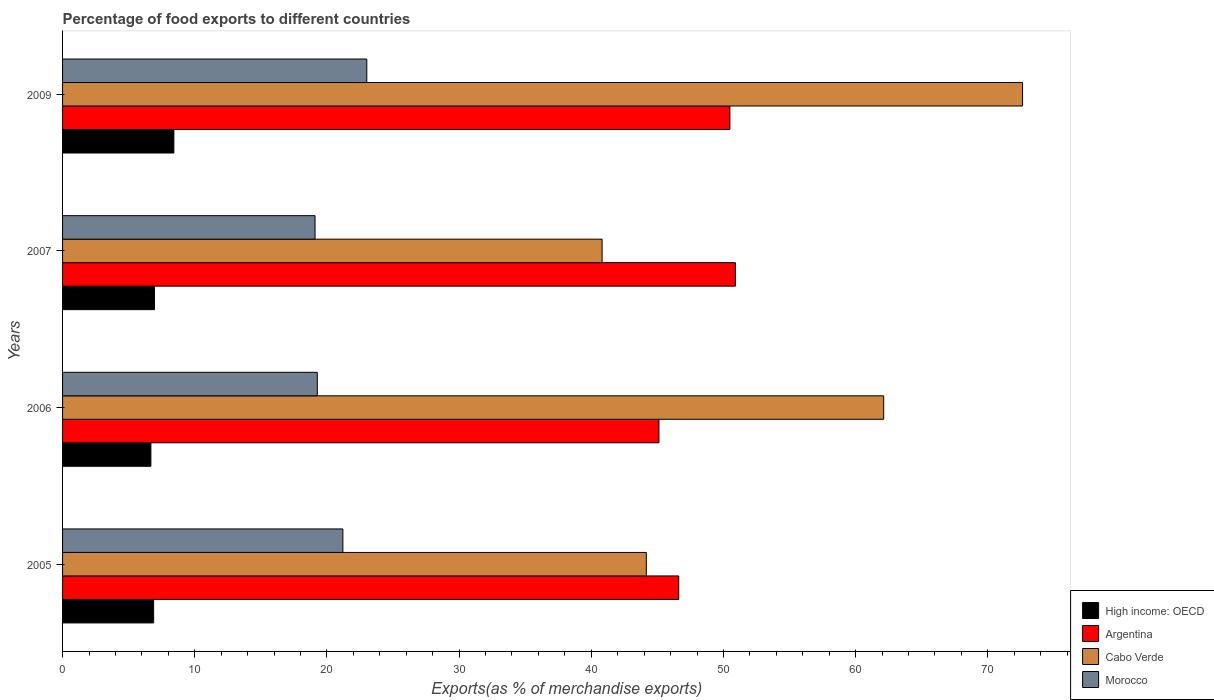Are the number of bars per tick equal to the number of legend labels?
Offer a terse response. Yes. How many bars are there on the 1st tick from the top?
Offer a very short reply. 4. How many bars are there on the 1st tick from the bottom?
Ensure brevity in your answer.  4. What is the percentage of exports to different countries in Morocco in 2006?
Ensure brevity in your answer.  19.27. Across all years, what is the maximum percentage of exports to different countries in High income: OECD?
Offer a terse response. 8.42. Across all years, what is the minimum percentage of exports to different countries in Cabo Verde?
Provide a succinct answer. 40.82. In which year was the percentage of exports to different countries in Argentina maximum?
Give a very brief answer. 2007. In which year was the percentage of exports to different countries in Cabo Verde minimum?
Keep it short and to the point. 2007. What is the total percentage of exports to different countries in Cabo Verde in the graph?
Your response must be concise. 219.74. What is the difference between the percentage of exports to different countries in Cabo Verde in 2006 and that in 2009?
Offer a terse response. -10.51. What is the difference between the percentage of exports to different countries in High income: OECD in 2005 and the percentage of exports to different countries in Cabo Verde in 2009?
Provide a succinct answer. -65.74. What is the average percentage of exports to different countries in Cabo Verde per year?
Make the answer very short. 54.94. In the year 2006, what is the difference between the percentage of exports to different countries in Cabo Verde and percentage of exports to different countries in Morocco?
Ensure brevity in your answer.  42.85. In how many years, is the percentage of exports to different countries in Cabo Verde greater than 36 %?
Give a very brief answer. 4. What is the ratio of the percentage of exports to different countries in Cabo Verde in 2006 to that in 2007?
Provide a succinct answer. 1.52. What is the difference between the highest and the second highest percentage of exports to different countries in Cabo Verde?
Your answer should be compact. 10.51. What is the difference between the highest and the lowest percentage of exports to different countries in Morocco?
Ensure brevity in your answer.  3.91. In how many years, is the percentage of exports to different countries in High income: OECD greater than the average percentage of exports to different countries in High income: OECD taken over all years?
Make the answer very short. 1. Is it the case that in every year, the sum of the percentage of exports to different countries in Morocco and percentage of exports to different countries in Cabo Verde is greater than the sum of percentage of exports to different countries in Argentina and percentage of exports to different countries in High income: OECD?
Offer a terse response. Yes. What does the 4th bar from the top in 2009 represents?
Make the answer very short. High income: OECD. How many bars are there?
Your answer should be very brief. 16. What is the difference between two consecutive major ticks on the X-axis?
Make the answer very short. 10. Are the values on the major ticks of X-axis written in scientific E-notation?
Keep it short and to the point. No. What is the title of the graph?
Give a very brief answer. Percentage of food exports to different countries. Does "Arab World" appear as one of the legend labels in the graph?
Ensure brevity in your answer.  No. What is the label or title of the X-axis?
Provide a succinct answer. Exports(as % of merchandise exports). What is the Exports(as % of merchandise exports) of High income: OECD in 2005?
Your answer should be very brief. 6.89. What is the Exports(as % of merchandise exports) in Argentina in 2005?
Offer a very short reply. 46.62. What is the Exports(as % of merchandise exports) of Cabo Verde in 2005?
Make the answer very short. 44.17. What is the Exports(as % of merchandise exports) of Morocco in 2005?
Provide a succinct answer. 21.21. What is the Exports(as % of merchandise exports) of High income: OECD in 2006?
Provide a succinct answer. 6.68. What is the Exports(as % of merchandise exports) of Argentina in 2006?
Make the answer very short. 45.12. What is the Exports(as % of merchandise exports) of Cabo Verde in 2006?
Ensure brevity in your answer.  62.12. What is the Exports(as % of merchandise exports) in Morocco in 2006?
Your answer should be compact. 19.27. What is the Exports(as % of merchandise exports) in High income: OECD in 2007?
Offer a very short reply. 6.95. What is the Exports(as % of merchandise exports) in Argentina in 2007?
Your answer should be compact. 50.91. What is the Exports(as % of merchandise exports) in Cabo Verde in 2007?
Offer a very short reply. 40.82. What is the Exports(as % of merchandise exports) in Morocco in 2007?
Keep it short and to the point. 19.1. What is the Exports(as % of merchandise exports) in High income: OECD in 2009?
Make the answer very short. 8.42. What is the Exports(as % of merchandise exports) in Argentina in 2009?
Your answer should be very brief. 50.49. What is the Exports(as % of merchandise exports) of Cabo Verde in 2009?
Your answer should be compact. 72.63. What is the Exports(as % of merchandise exports) of Morocco in 2009?
Your answer should be compact. 23.02. Across all years, what is the maximum Exports(as % of merchandise exports) of High income: OECD?
Give a very brief answer. 8.42. Across all years, what is the maximum Exports(as % of merchandise exports) in Argentina?
Keep it short and to the point. 50.91. Across all years, what is the maximum Exports(as % of merchandise exports) in Cabo Verde?
Keep it short and to the point. 72.63. Across all years, what is the maximum Exports(as % of merchandise exports) of Morocco?
Your response must be concise. 23.02. Across all years, what is the minimum Exports(as % of merchandise exports) in High income: OECD?
Keep it short and to the point. 6.68. Across all years, what is the minimum Exports(as % of merchandise exports) in Argentina?
Offer a terse response. 45.12. Across all years, what is the minimum Exports(as % of merchandise exports) of Cabo Verde?
Provide a succinct answer. 40.82. Across all years, what is the minimum Exports(as % of merchandise exports) in Morocco?
Your answer should be compact. 19.1. What is the total Exports(as % of merchandise exports) in High income: OECD in the graph?
Offer a very short reply. 28.95. What is the total Exports(as % of merchandise exports) in Argentina in the graph?
Provide a succinct answer. 193.13. What is the total Exports(as % of merchandise exports) of Cabo Verde in the graph?
Offer a terse response. 219.74. What is the total Exports(as % of merchandise exports) of Morocco in the graph?
Offer a very short reply. 82.6. What is the difference between the Exports(as % of merchandise exports) of High income: OECD in 2005 and that in 2006?
Your answer should be compact. 0.21. What is the difference between the Exports(as % of merchandise exports) in Argentina in 2005 and that in 2006?
Provide a short and direct response. 1.5. What is the difference between the Exports(as % of merchandise exports) of Cabo Verde in 2005 and that in 2006?
Ensure brevity in your answer.  -17.96. What is the difference between the Exports(as % of merchandise exports) of Morocco in 2005 and that in 2006?
Offer a very short reply. 1.93. What is the difference between the Exports(as % of merchandise exports) in High income: OECD in 2005 and that in 2007?
Offer a terse response. -0.06. What is the difference between the Exports(as % of merchandise exports) in Argentina in 2005 and that in 2007?
Provide a short and direct response. -4.29. What is the difference between the Exports(as % of merchandise exports) of Cabo Verde in 2005 and that in 2007?
Give a very brief answer. 3.35. What is the difference between the Exports(as % of merchandise exports) of Morocco in 2005 and that in 2007?
Give a very brief answer. 2.1. What is the difference between the Exports(as % of merchandise exports) in High income: OECD in 2005 and that in 2009?
Your answer should be very brief. -1.53. What is the difference between the Exports(as % of merchandise exports) in Argentina in 2005 and that in 2009?
Make the answer very short. -3.87. What is the difference between the Exports(as % of merchandise exports) of Cabo Verde in 2005 and that in 2009?
Offer a very short reply. -28.47. What is the difference between the Exports(as % of merchandise exports) in Morocco in 2005 and that in 2009?
Offer a very short reply. -1.81. What is the difference between the Exports(as % of merchandise exports) of High income: OECD in 2006 and that in 2007?
Provide a succinct answer. -0.27. What is the difference between the Exports(as % of merchandise exports) in Argentina in 2006 and that in 2007?
Provide a short and direct response. -5.79. What is the difference between the Exports(as % of merchandise exports) in Cabo Verde in 2006 and that in 2007?
Provide a short and direct response. 21.31. What is the difference between the Exports(as % of merchandise exports) of Morocco in 2006 and that in 2007?
Provide a short and direct response. 0.17. What is the difference between the Exports(as % of merchandise exports) of High income: OECD in 2006 and that in 2009?
Your response must be concise. -1.74. What is the difference between the Exports(as % of merchandise exports) in Argentina in 2006 and that in 2009?
Your answer should be very brief. -5.37. What is the difference between the Exports(as % of merchandise exports) in Cabo Verde in 2006 and that in 2009?
Your response must be concise. -10.51. What is the difference between the Exports(as % of merchandise exports) in Morocco in 2006 and that in 2009?
Your answer should be very brief. -3.74. What is the difference between the Exports(as % of merchandise exports) of High income: OECD in 2007 and that in 2009?
Your answer should be compact. -1.47. What is the difference between the Exports(as % of merchandise exports) in Argentina in 2007 and that in 2009?
Offer a terse response. 0.42. What is the difference between the Exports(as % of merchandise exports) in Cabo Verde in 2007 and that in 2009?
Your response must be concise. -31.81. What is the difference between the Exports(as % of merchandise exports) in Morocco in 2007 and that in 2009?
Your answer should be compact. -3.91. What is the difference between the Exports(as % of merchandise exports) in High income: OECD in 2005 and the Exports(as % of merchandise exports) in Argentina in 2006?
Provide a succinct answer. -38.23. What is the difference between the Exports(as % of merchandise exports) of High income: OECD in 2005 and the Exports(as % of merchandise exports) of Cabo Verde in 2006?
Your response must be concise. -55.24. What is the difference between the Exports(as % of merchandise exports) of High income: OECD in 2005 and the Exports(as % of merchandise exports) of Morocco in 2006?
Offer a terse response. -12.38. What is the difference between the Exports(as % of merchandise exports) in Argentina in 2005 and the Exports(as % of merchandise exports) in Cabo Verde in 2006?
Offer a terse response. -15.51. What is the difference between the Exports(as % of merchandise exports) in Argentina in 2005 and the Exports(as % of merchandise exports) in Morocco in 2006?
Ensure brevity in your answer.  27.35. What is the difference between the Exports(as % of merchandise exports) of Cabo Verde in 2005 and the Exports(as % of merchandise exports) of Morocco in 2006?
Keep it short and to the point. 24.89. What is the difference between the Exports(as % of merchandise exports) in High income: OECD in 2005 and the Exports(as % of merchandise exports) in Argentina in 2007?
Provide a short and direct response. -44.02. What is the difference between the Exports(as % of merchandise exports) of High income: OECD in 2005 and the Exports(as % of merchandise exports) of Cabo Verde in 2007?
Your answer should be compact. -33.93. What is the difference between the Exports(as % of merchandise exports) in High income: OECD in 2005 and the Exports(as % of merchandise exports) in Morocco in 2007?
Your answer should be very brief. -12.21. What is the difference between the Exports(as % of merchandise exports) in Argentina in 2005 and the Exports(as % of merchandise exports) in Cabo Verde in 2007?
Keep it short and to the point. 5.8. What is the difference between the Exports(as % of merchandise exports) in Argentina in 2005 and the Exports(as % of merchandise exports) in Morocco in 2007?
Provide a short and direct response. 27.52. What is the difference between the Exports(as % of merchandise exports) in Cabo Verde in 2005 and the Exports(as % of merchandise exports) in Morocco in 2007?
Your answer should be very brief. 25.06. What is the difference between the Exports(as % of merchandise exports) of High income: OECD in 2005 and the Exports(as % of merchandise exports) of Argentina in 2009?
Give a very brief answer. -43.6. What is the difference between the Exports(as % of merchandise exports) of High income: OECD in 2005 and the Exports(as % of merchandise exports) of Cabo Verde in 2009?
Provide a short and direct response. -65.74. What is the difference between the Exports(as % of merchandise exports) of High income: OECD in 2005 and the Exports(as % of merchandise exports) of Morocco in 2009?
Offer a very short reply. -16.13. What is the difference between the Exports(as % of merchandise exports) in Argentina in 2005 and the Exports(as % of merchandise exports) in Cabo Verde in 2009?
Your answer should be very brief. -26.01. What is the difference between the Exports(as % of merchandise exports) of Argentina in 2005 and the Exports(as % of merchandise exports) of Morocco in 2009?
Make the answer very short. 23.6. What is the difference between the Exports(as % of merchandise exports) of Cabo Verde in 2005 and the Exports(as % of merchandise exports) of Morocco in 2009?
Provide a short and direct response. 21.15. What is the difference between the Exports(as % of merchandise exports) of High income: OECD in 2006 and the Exports(as % of merchandise exports) of Argentina in 2007?
Your response must be concise. -44.22. What is the difference between the Exports(as % of merchandise exports) in High income: OECD in 2006 and the Exports(as % of merchandise exports) in Cabo Verde in 2007?
Your answer should be compact. -34.14. What is the difference between the Exports(as % of merchandise exports) of High income: OECD in 2006 and the Exports(as % of merchandise exports) of Morocco in 2007?
Make the answer very short. -12.42. What is the difference between the Exports(as % of merchandise exports) of Argentina in 2006 and the Exports(as % of merchandise exports) of Cabo Verde in 2007?
Offer a terse response. 4.3. What is the difference between the Exports(as % of merchandise exports) in Argentina in 2006 and the Exports(as % of merchandise exports) in Morocco in 2007?
Your response must be concise. 26.02. What is the difference between the Exports(as % of merchandise exports) of Cabo Verde in 2006 and the Exports(as % of merchandise exports) of Morocco in 2007?
Provide a succinct answer. 43.02. What is the difference between the Exports(as % of merchandise exports) of High income: OECD in 2006 and the Exports(as % of merchandise exports) of Argentina in 2009?
Your answer should be very brief. -43.81. What is the difference between the Exports(as % of merchandise exports) in High income: OECD in 2006 and the Exports(as % of merchandise exports) in Cabo Verde in 2009?
Ensure brevity in your answer.  -65.95. What is the difference between the Exports(as % of merchandise exports) in High income: OECD in 2006 and the Exports(as % of merchandise exports) in Morocco in 2009?
Give a very brief answer. -16.34. What is the difference between the Exports(as % of merchandise exports) in Argentina in 2006 and the Exports(as % of merchandise exports) in Cabo Verde in 2009?
Ensure brevity in your answer.  -27.51. What is the difference between the Exports(as % of merchandise exports) of Argentina in 2006 and the Exports(as % of merchandise exports) of Morocco in 2009?
Ensure brevity in your answer.  22.1. What is the difference between the Exports(as % of merchandise exports) of Cabo Verde in 2006 and the Exports(as % of merchandise exports) of Morocco in 2009?
Make the answer very short. 39.11. What is the difference between the Exports(as % of merchandise exports) in High income: OECD in 2007 and the Exports(as % of merchandise exports) in Argentina in 2009?
Offer a terse response. -43.54. What is the difference between the Exports(as % of merchandise exports) of High income: OECD in 2007 and the Exports(as % of merchandise exports) of Cabo Verde in 2009?
Your response must be concise. -65.68. What is the difference between the Exports(as % of merchandise exports) of High income: OECD in 2007 and the Exports(as % of merchandise exports) of Morocco in 2009?
Offer a very short reply. -16.06. What is the difference between the Exports(as % of merchandise exports) of Argentina in 2007 and the Exports(as % of merchandise exports) of Cabo Verde in 2009?
Keep it short and to the point. -21.73. What is the difference between the Exports(as % of merchandise exports) of Argentina in 2007 and the Exports(as % of merchandise exports) of Morocco in 2009?
Make the answer very short. 27.89. What is the difference between the Exports(as % of merchandise exports) in Cabo Verde in 2007 and the Exports(as % of merchandise exports) in Morocco in 2009?
Offer a terse response. 17.8. What is the average Exports(as % of merchandise exports) of High income: OECD per year?
Offer a very short reply. 7.24. What is the average Exports(as % of merchandise exports) in Argentina per year?
Provide a succinct answer. 48.28. What is the average Exports(as % of merchandise exports) in Cabo Verde per year?
Offer a terse response. 54.94. What is the average Exports(as % of merchandise exports) of Morocco per year?
Keep it short and to the point. 20.65. In the year 2005, what is the difference between the Exports(as % of merchandise exports) in High income: OECD and Exports(as % of merchandise exports) in Argentina?
Make the answer very short. -39.73. In the year 2005, what is the difference between the Exports(as % of merchandise exports) of High income: OECD and Exports(as % of merchandise exports) of Cabo Verde?
Your answer should be compact. -37.28. In the year 2005, what is the difference between the Exports(as % of merchandise exports) of High income: OECD and Exports(as % of merchandise exports) of Morocco?
Offer a terse response. -14.32. In the year 2005, what is the difference between the Exports(as % of merchandise exports) of Argentina and Exports(as % of merchandise exports) of Cabo Verde?
Your answer should be very brief. 2.45. In the year 2005, what is the difference between the Exports(as % of merchandise exports) in Argentina and Exports(as % of merchandise exports) in Morocco?
Give a very brief answer. 25.41. In the year 2005, what is the difference between the Exports(as % of merchandise exports) in Cabo Verde and Exports(as % of merchandise exports) in Morocco?
Your response must be concise. 22.96. In the year 2006, what is the difference between the Exports(as % of merchandise exports) of High income: OECD and Exports(as % of merchandise exports) of Argentina?
Your answer should be very brief. -38.44. In the year 2006, what is the difference between the Exports(as % of merchandise exports) of High income: OECD and Exports(as % of merchandise exports) of Cabo Verde?
Provide a succinct answer. -55.44. In the year 2006, what is the difference between the Exports(as % of merchandise exports) of High income: OECD and Exports(as % of merchandise exports) of Morocco?
Your response must be concise. -12.59. In the year 2006, what is the difference between the Exports(as % of merchandise exports) in Argentina and Exports(as % of merchandise exports) in Cabo Verde?
Your answer should be very brief. -17.01. In the year 2006, what is the difference between the Exports(as % of merchandise exports) of Argentina and Exports(as % of merchandise exports) of Morocco?
Offer a terse response. 25.85. In the year 2006, what is the difference between the Exports(as % of merchandise exports) in Cabo Verde and Exports(as % of merchandise exports) in Morocco?
Offer a terse response. 42.85. In the year 2007, what is the difference between the Exports(as % of merchandise exports) in High income: OECD and Exports(as % of merchandise exports) in Argentina?
Make the answer very short. -43.95. In the year 2007, what is the difference between the Exports(as % of merchandise exports) of High income: OECD and Exports(as % of merchandise exports) of Cabo Verde?
Your answer should be very brief. -33.87. In the year 2007, what is the difference between the Exports(as % of merchandise exports) of High income: OECD and Exports(as % of merchandise exports) of Morocco?
Offer a terse response. -12.15. In the year 2007, what is the difference between the Exports(as % of merchandise exports) in Argentina and Exports(as % of merchandise exports) in Cabo Verde?
Your answer should be very brief. 10.09. In the year 2007, what is the difference between the Exports(as % of merchandise exports) in Argentina and Exports(as % of merchandise exports) in Morocco?
Provide a succinct answer. 31.8. In the year 2007, what is the difference between the Exports(as % of merchandise exports) of Cabo Verde and Exports(as % of merchandise exports) of Morocco?
Make the answer very short. 21.72. In the year 2009, what is the difference between the Exports(as % of merchandise exports) in High income: OECD and Exports(as % of merchandise exports) in Argentina?
Make the answer very short. -42.07. In the year 2009, what is the difference between the Exports(as % of merchandise exports) in High income: OECD and Exports(as % of merchandise exports) in Cabo Verde?
Provide a short and direct response. -64.21. In the year 2009, what is the difference between the Exports(as % of merchandise exports) in High income: OECD and Exports(as % of merchandise exports) in Morocco?
Give a very brief answer. -14.6. In the year 2009, what is the difference between the Exports(as % of merchandise exports) of Argentina and Exports(as % of merchandise exports) of Cabo Verde?
Ensure brevity in your answer.  -22.14. In the year 2009, what is the difference between the Exports(as % of merchandise exports) in Argentina and Exports(as % of merchandise exports) in Morocco?
Your response must be concise. 27.47. In the year 2009, what is the difference between the Exports(as % of merchandise exports) of Cabo Verde and Exports(as % of merchandise exports) of Morocco?
Offer a very short reply. 49.62. What is the ratio of the Exports(as % of merchandise exports) of High income: OECD in 2005 to that in 2006?
Give a very brief answer. 1.03. What is the ratio of the Exports(as % of merchandise exports) in Argentina in 2005 to that in 2006?
Your answer should be very brief. 1.03. What is the ratio of the Exports(as % of merchandise exports) in Cabo Verde in 2005 to that in 2006?
Provide a short and direct response. 0.71. What is the ratio of the Exports(as % of merchandise exports) of Morocco in 2005 to that in 2006?
Offer a terse response. 1.1. What is the ratio of the Exports(as % of merchandise exports) of High income: OECD in 2005 to that in 2007?
Keep it short and to the point. 0.99. What is the ratio of the Exports(as % of merchandise exports) of Argentina in 2005 to that in 2007?
Give a very brief answer. 0.92. What is the ratio of the Exports(as % of merchandise exports) in Cabo Verde in 2005 to that in 2007?
Ensure brevity in your answer.  1.08. What is the ratio of the Exports(as % of merchandise exports) in Morocco in 2005 to that in 2007?
Keep it short and to the point. 1.11. What is the ratio of the Exports(as % of merchandise exports) of High income: OECD in 2005 to that in 2009?
Offer a very short reply. 0.82. What is the ratio of the Exports(as % of merchandise exports) in Argentina in 2005 to that in 2009?
Make the answer very short. 0.92. What is the ratio of the Exports(as % of merchandise exports) of Cabo Verde in 2005 to that in 2009?
Your answer should be compact. 0.61. What is the ratio of the Exports(as % of merchandise exports) in Morocco in 2005 to that in 2009?
Give a very brief answer. 0.92. What is the ratio of the Exports(as % of merchandise exports) in High income: OECD in 2006 to that in 2007?
Keep it short and to the point. 0.96. What is the ratio of the Exports(as % of merchandise exports) in Argentina in 2006 to that in 2007?
Provide a short and direct response. 0.89. What is the ratio of the Exports(as % of merchandise exports) of Cabo Verde in 2006 to that in 2007?
Offer a terse response. 1.52. What is the ratio of the Exports(as % of merchandise exports) of Morocco in 2006 to that in 2007?
Your answer should be compact. 1.01. What is the ratio of the Exports(as % of merchandise exports) of High income: OECD in 2006 to that in 2009?
Provide a short and direct response. 0.79. What is the ratio of the Exports(as % of merchandise exports) of Argentina in 2006 to that in 2009?
Make the answer very short. 0.89. What is the ratio of the Exports(as % of merchandise exports) in Cabo Verde in 2006 to that in 2009?
Ensure brevity in your answer.  0.86. What is the ratio of the Exports(as % of merchandise exports) of Morocco in 2006 to that in 2009?
Keep it short and to the point. 0.84. What is the ratio of the Exports(as % of merchandise exports) of High income: OECD in 2007 to that in 2009?
Ensure brevity in your answer.  0.83. What is the ratio of the Exports(as % of merchandise exports) in Argentina in 2007 to that in 2009?
Make the answer very short. 1.01. What is the ratio of the Exports(as % of merchandise exports) of Cabo Verde in 2007 to that in 2009?
Make the answer very short. 0.56. What is the ratio of the Exports(as % of merchandise exports) of Morocco in 2007 to that in 2009?
Provide a succinct answer. 0.83. What is the difference between the highest and the second highest Exports(as % of merchandise exports) in High income: OECD?
Make the answer very short. 1.47. What is the difference between the highest and the second highest Exports(as % of merchandise exports) in Argentina?
Give a very brief answer. 0.42. What is the difference between the highest and the second highest Exports(as % of merchandise exports) of Cabo Verde?
Your response must be concise. 10.51. What is the difference between the highest and the second highest Exports(as % of merchandise exports) in Morocco?
Provide a short and direct response. 1.81. What is the difference between the highest and the lowest Exports(as % of merchandise exports) in High income: OECD?
Provide a succinct answer. 1.74. What is the difference between the highest and the lowest Exports(as % of merchandise exports) in Argentina?
Provide a succinct answer. 5.79. What is the difference between the highest and the lowest Exports(as % of merchandise exports) in Cabo Verde?
Offer a very short reply. 31.81. What is the difference between the highest and the lowest Exports(as % of merchandise exports) of Morocco?
Your response must be concise. 3.91. 